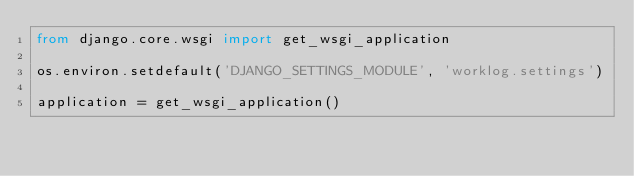Convert code to text. <code><loc_0><loc_0><loc_500><loc_500><_Python_>from django.core.wsgi import get_wsgi_application

os.environ.setdefault('DJANGO_SETTINGS_MODULE', 'worklog.settings')

application = get_wsgi_application()
</code> 